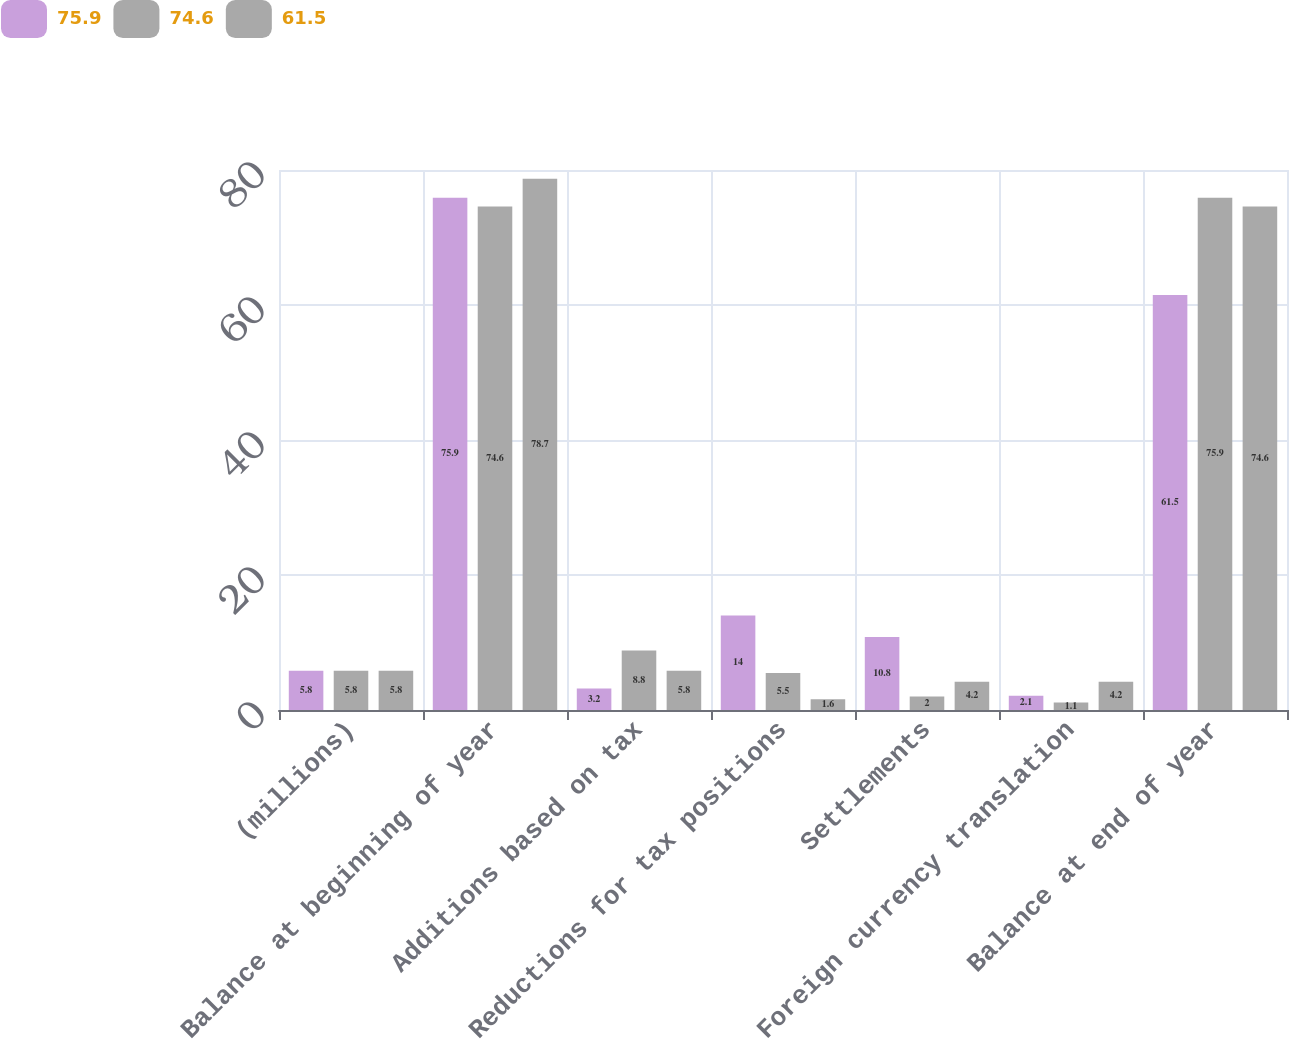Convert chart. <chart><loc_0><loc_0><loc_500><loc_500><stacked_bar_chart><ecel><fcel>(millions)<fcel>Balance at beginning of year<fcel>Additions based on tax<fcel>Reductions for tax positions<fcel>Settlements<fcel>Foreign currency translation<fcel>Balance at end of year<nl><fcel>75.9<fcel>5.8<fcel>75.9<fcel>3.2<fcel>14<fcel>10.8<fcel>2.1<fcel>61.5<nl><fcel>74.6<fcel>5.8<fcel>74.6<fcel>8.8<fcel>5.5<fcel>2<fcel>1.1<fcel>75.9<nl><fcel>61.5<fcel>5.8<fcel>78.7<fcel>5.8<fcel>1.6<fcel>4.2<fcel>4.2<fcel>74.6<nl></chart> 